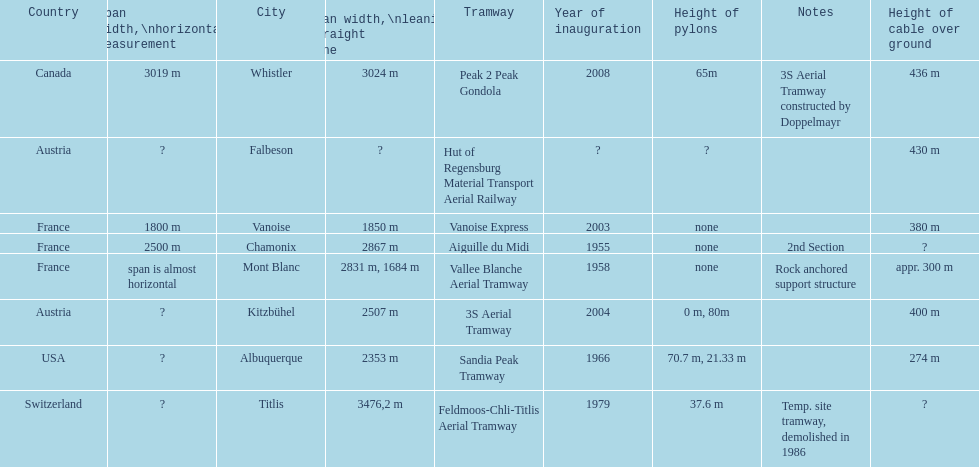Was the sandia peak tramway innagurate before or after the 3s aerial tramway? Before. 